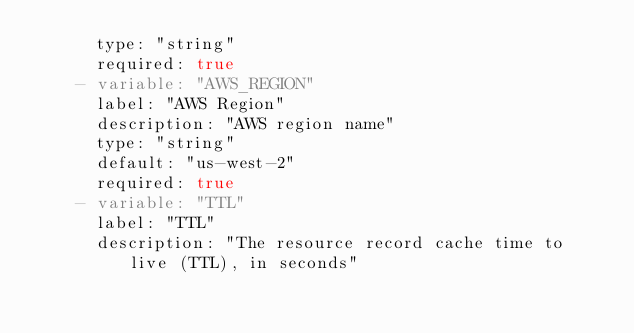Convert code to text. <code><loc_0><loc_0><loc_500><loc_500><_YAML_>      type: "string"
      required: true
    - variable: "AWS_REGION"
      label: "AWS Region"
      description: "AWS region name"
      type: "string"
      default: "us-west-2"
      required: true
    - variable: "TTL"
      label: "TTL"
      description: "The resource record cache time to live (TTL), in seconds"</code> 